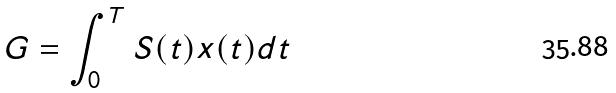Convert formula to latex. <formula><loc_0><loc_0><loc_500><loc_500>G = \int _ { 0 } ^ { T } S ( t ) x ( t ) d t</formula> 